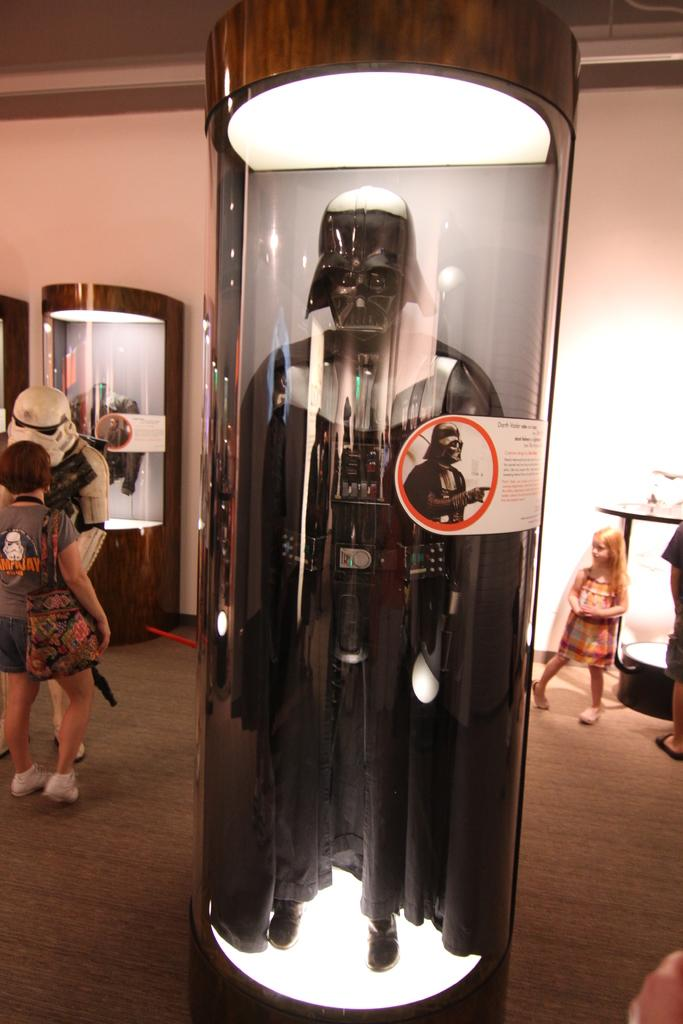What is inside the glass box in the image? There is a person's outfit in a glass box in the image. What can be seen in the background of the image? People are standing on the floor and there is a wall visible in the background of the image. What else is on the floor in the background of the image? There are other objects on the floor in the background of the image. Can you see a mitten being played on the drum in the image? There is no mitten or drum present in the image. 